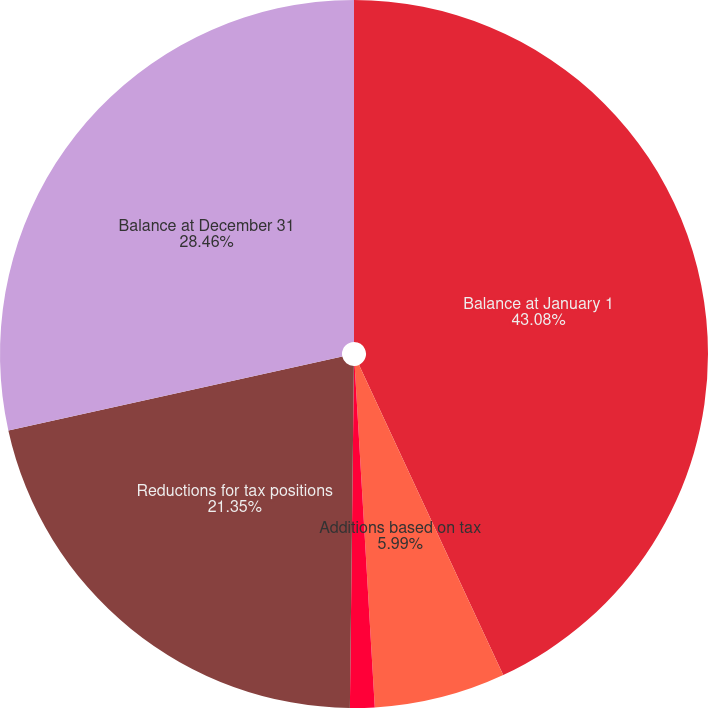<chart> <loc_0><loc_0><loc_500><loc_500><pie_chart><fcel>Balance at January 1<fcel>Additions based on tax<fcel>Additions for tax positions of<fcel>Reductions for tax positions<fcel>Balance at December 31<nl><fcel>43.07%<fcel>5.99%<fcel>1.12%<fcel>21.35%<fcel>28.46%<nl></chart> 